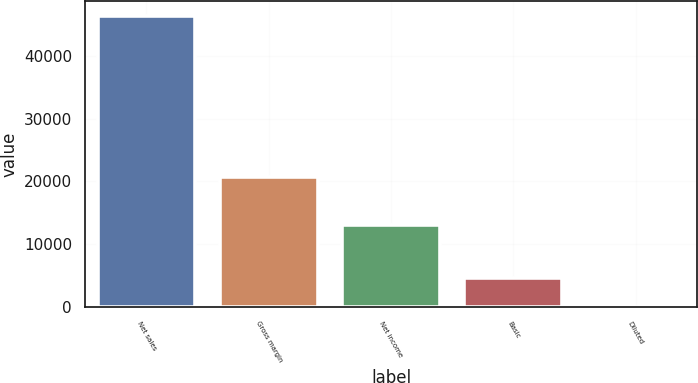Convert chart. <chart><loc_0><loc_0><loc_500><loc_500><bar_chart><fcel>Net sales<fcel>Gross margin<fcel>Net income<fcel>Basic<fcel>Diluted<nl><fcel>46333<fcel>20703<fcel>13064<fcel>4645.78<fcel>13.87<nl></chart> 